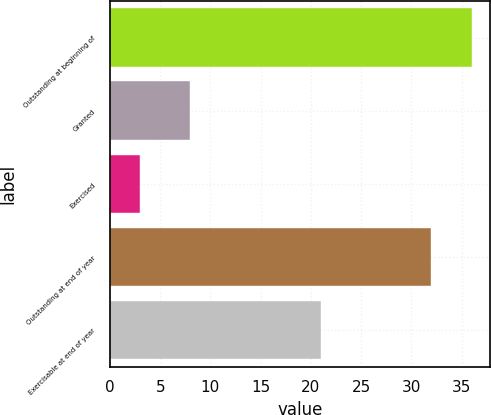Convert chart to OTSL. <chart><loc_0><loc_0><loc_500><loc_500><bar_chart><fcel>Outstanding at beginning of<fcel>Granted<fcel>Exercised<fcel>Outstanding at end of year<fcel>Exercisable at end of year<nl><fcel>36<fcel>8<fcel>3<fcel>32<fcel>21<nl></chart> 